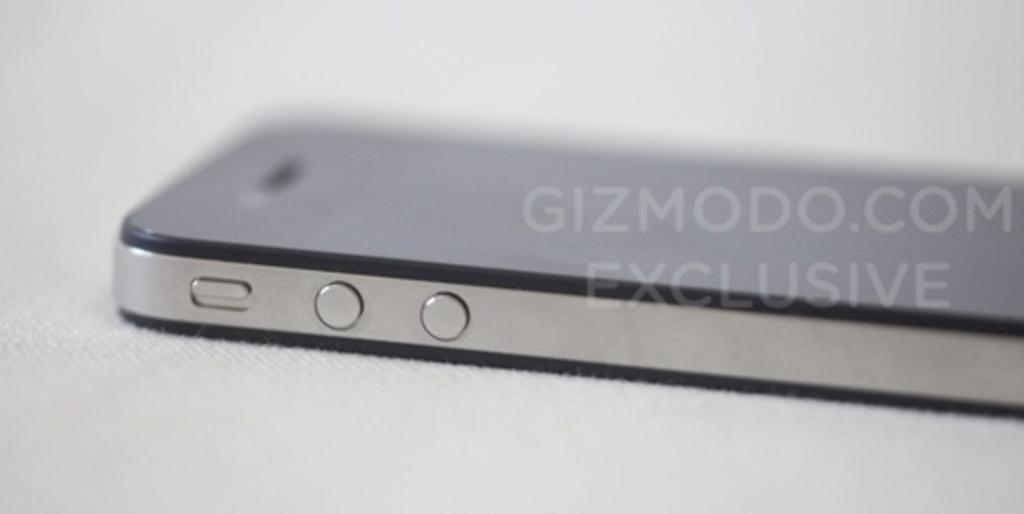<image>
Write a terse but informative summary of the picture. An electronic device turned on it's front side that says gizmodo.com exclusive in a watermark over it. 